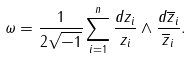Convert formula to latex. <formula><loc_0><loc_0><loc_500><loc_500>\omega = \frac { 1 } { 2 \sqrt { - 1 } } \sum _ { i = 1 } ^ { n } \frac { d z _ { i } } { z _ { i } } \wedge \frac { d \overline { z } _ { i } } { \overline { z } _ { i } } .</formula> 